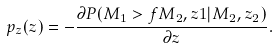<formula> <loc_0><loc_0><loc_500><loc_500>p _ { z } ( z ) = - \frac { \partial P ( M _ { 1 } > f M _ { 2 } , z 1 | M _ { 2 } , z _ { 2 } ) } { \partial z } .</formula> 